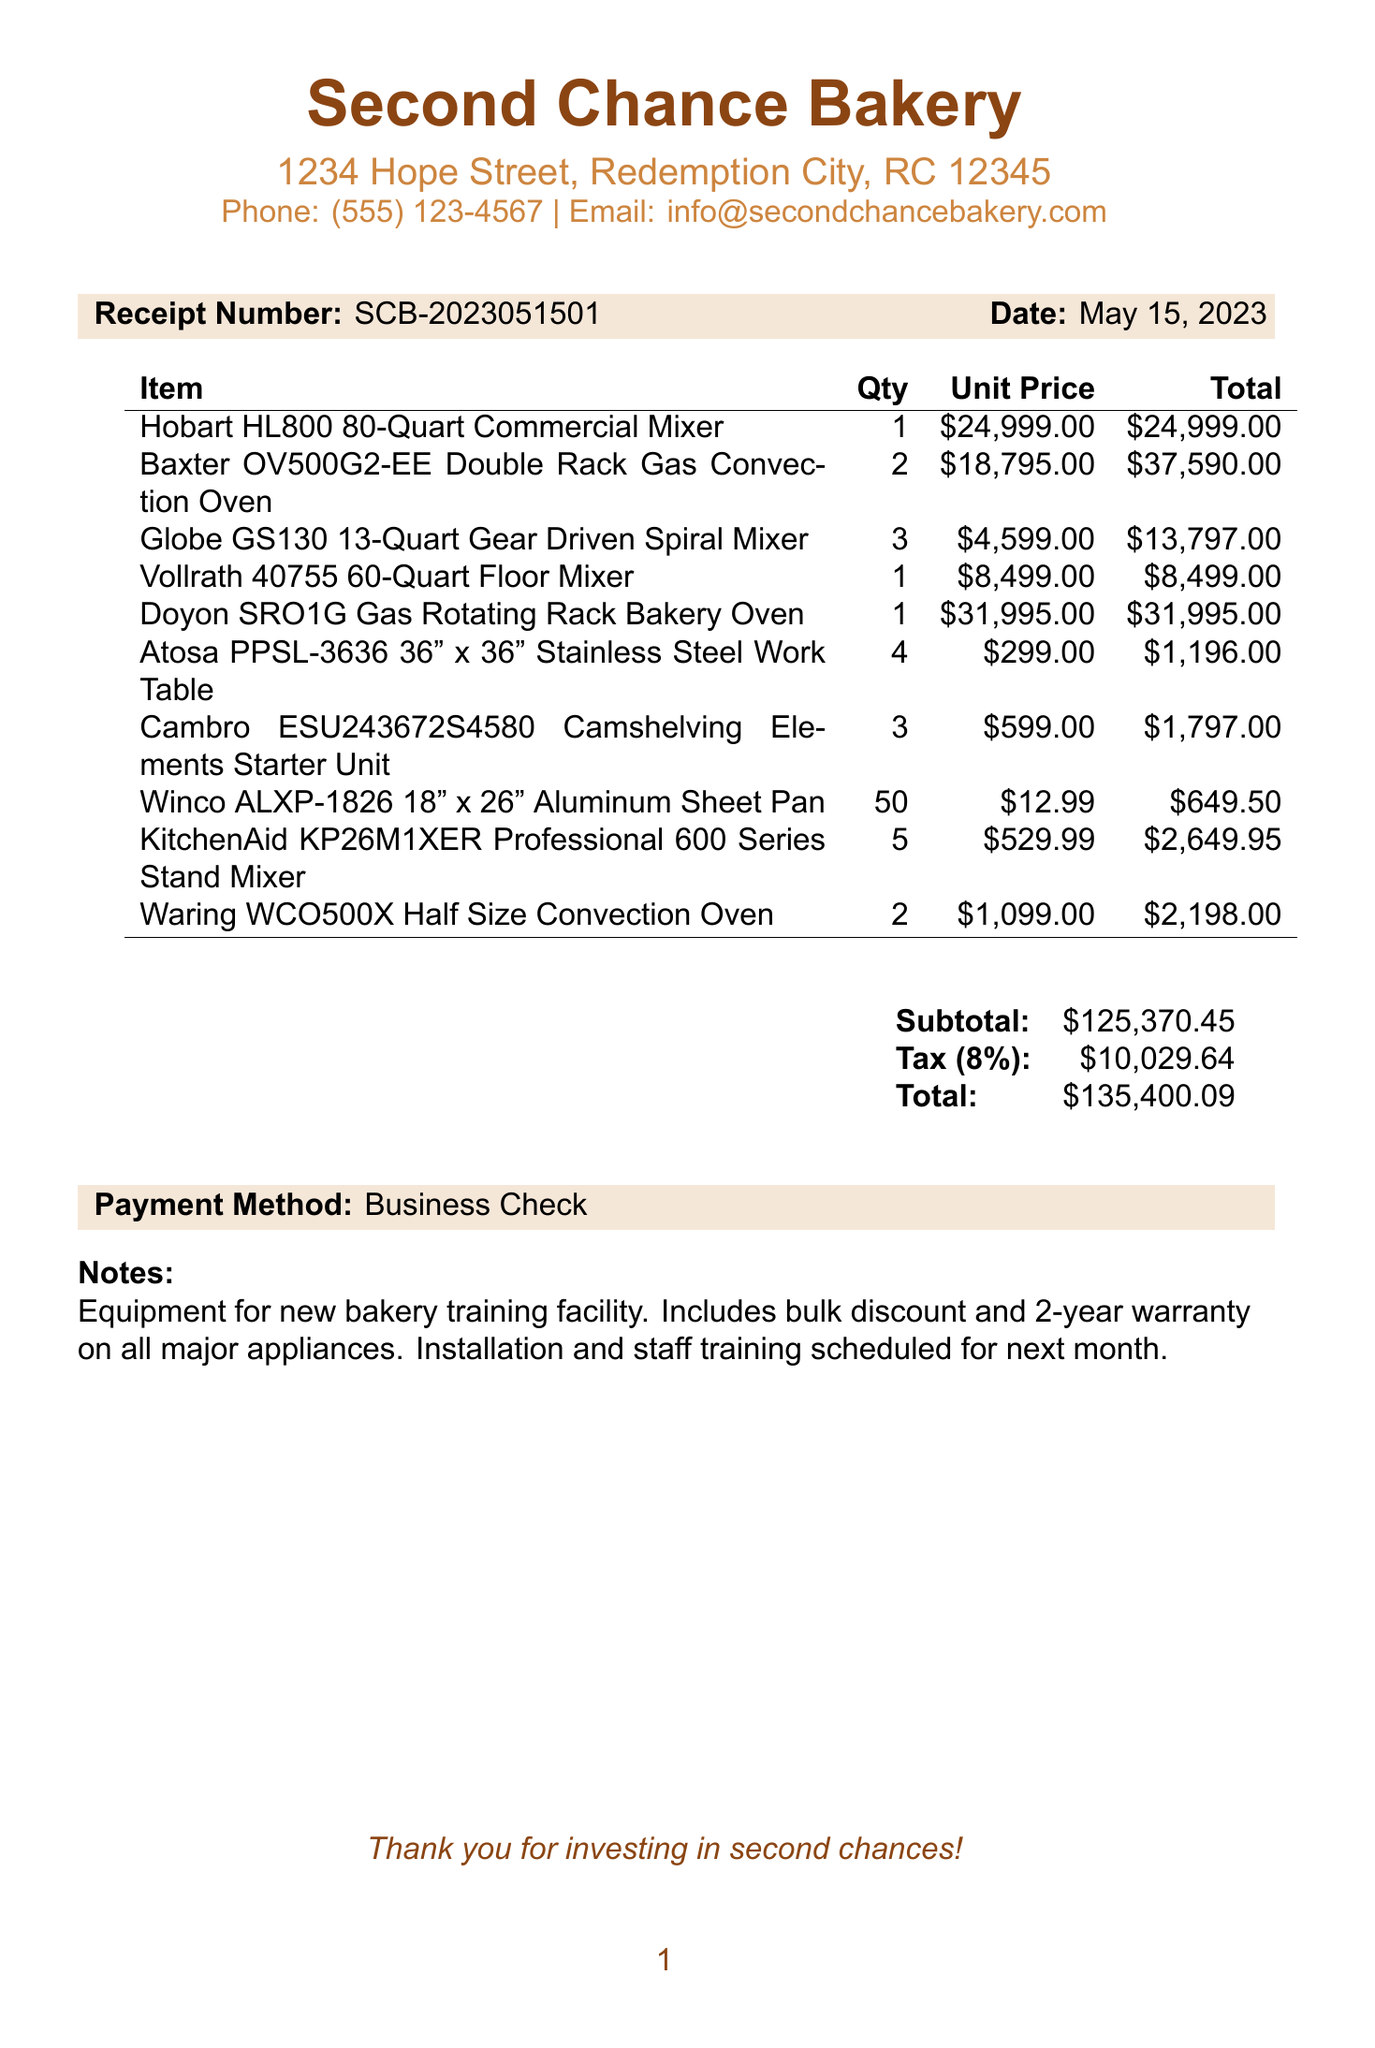What is the business name? The business name is prominently featured at the top of the document.
Answer: Second Chance Bakery What is the total amount of the receipt? The total amount is provided in the summary section at the bottom of the document.
Answer: $135,400.09 What is the date of the receipt? The date can be found in the header section along with the receipt number.
Answer: May 15, 2023 How many KitchenAid stand mixers were purchased? The quantity of KitchenAid stand mixers is listed in the itemized section of the document.
Answer: 5 What is the tax rate applied to the subtotal? The tax rate is specified in the summary section.
Answer: 8% What is the total quantity of the Winco sheet pans? The quantity for the Winco sheet pans is stated in the list of purchased items.
Answer: 50 What type of payment was used for this transaction? The payment method is mentioned in the summary section.
Answer: Business Check What is noted about the equipment purchased? The notes section describes the context of the purchase in a brief statement.
Answer: Equipment for new bakery training facility How many Baxter ovens were ordered? The quantity of Baxter ovens can be found in the itemized list of products purchased.
Answer: 2 What is the subtotal before tax? The subtotal amount is detailed in the summary section before the tax is added.
Answer: $125,370.45 